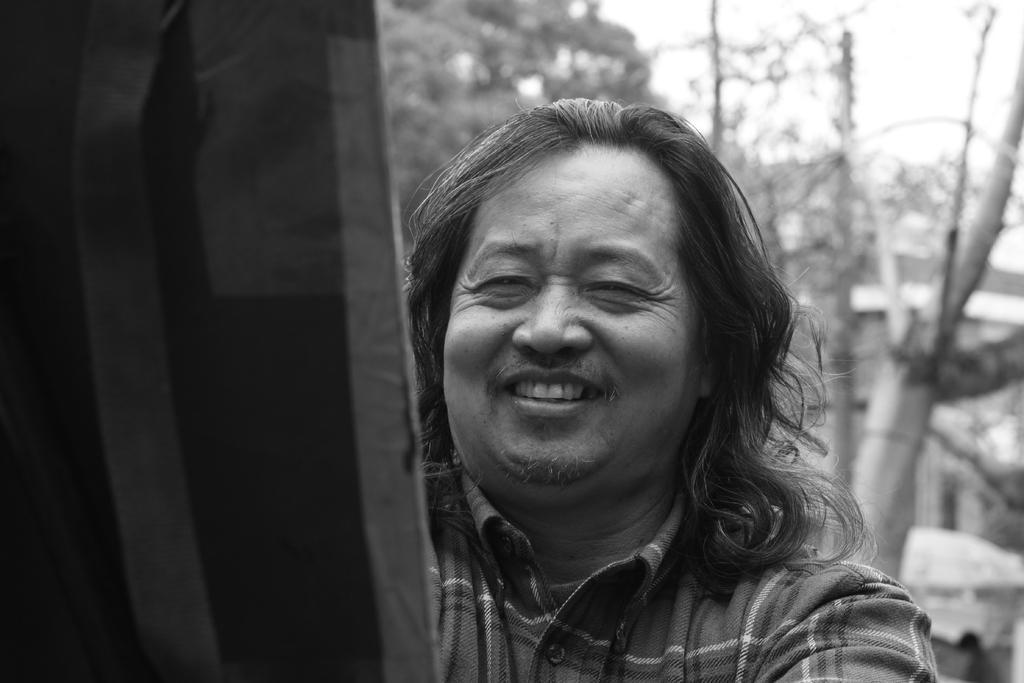Can you describe this image briefly? In this image we can see a person. There is an object at the left side of the image. There are many trees in the image. There is a building in the image. There is a sky in the image. There is an object at the right side of the image. 